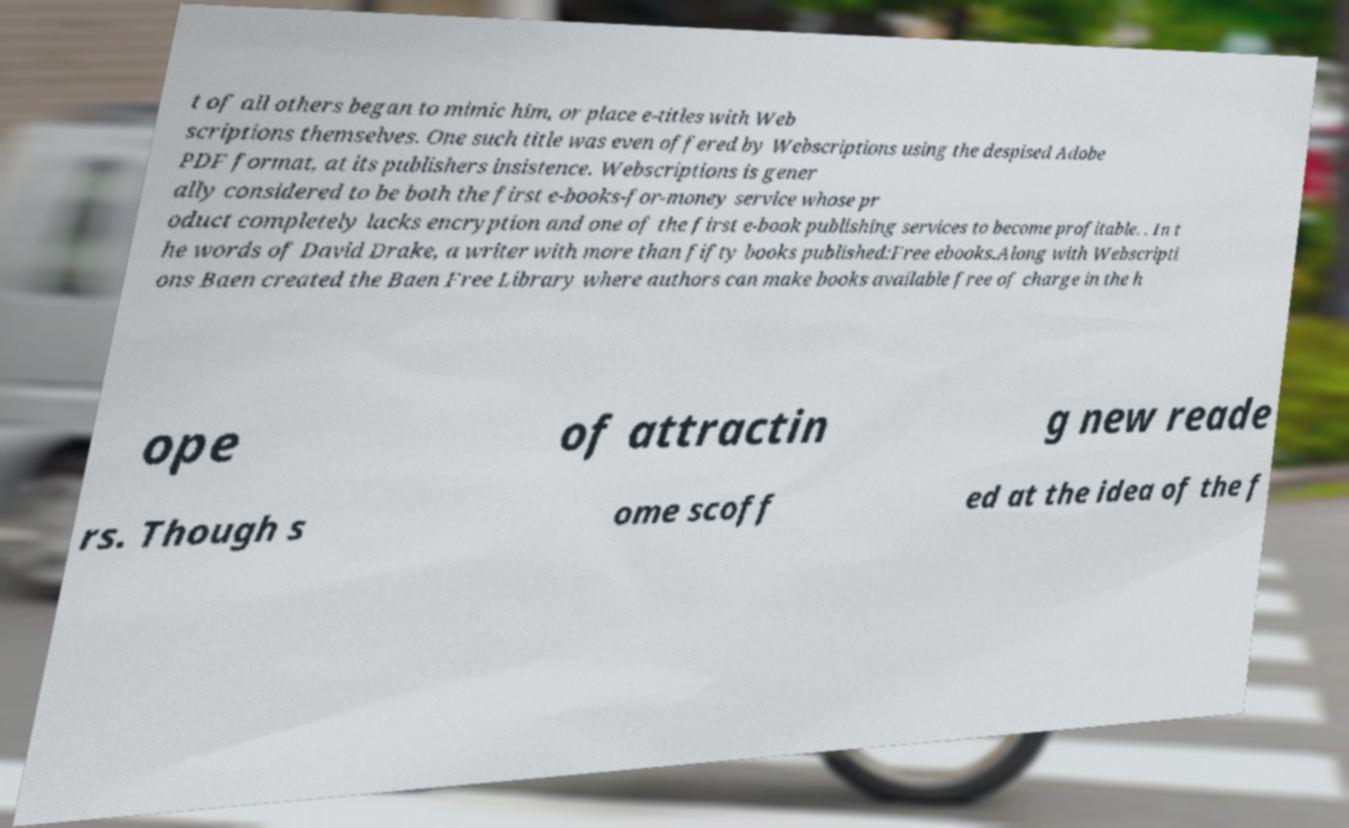Please read and relay the text visible in this image. What does it say? t of all others began to mimic him, or place e-titles with Web scriptions themselves. One such title was even offered by Webscriptions using the despised Adobe PDF format, at its publishers insistence. Webscriptions is gener ally considered to be both the first e-books-for-money service whose pr oduct completely lacks encryption and one of the first e-book publishing services to become profitable. . In t he words of David Drake, a writer with more than fifty books published:Free ebooks.Along with Webscripti ons Baen created the Baen Free Library where authors can make books available free of charge in the h ope of attractin g new reade rs. Though s ome scoff ed at the idea of the f 